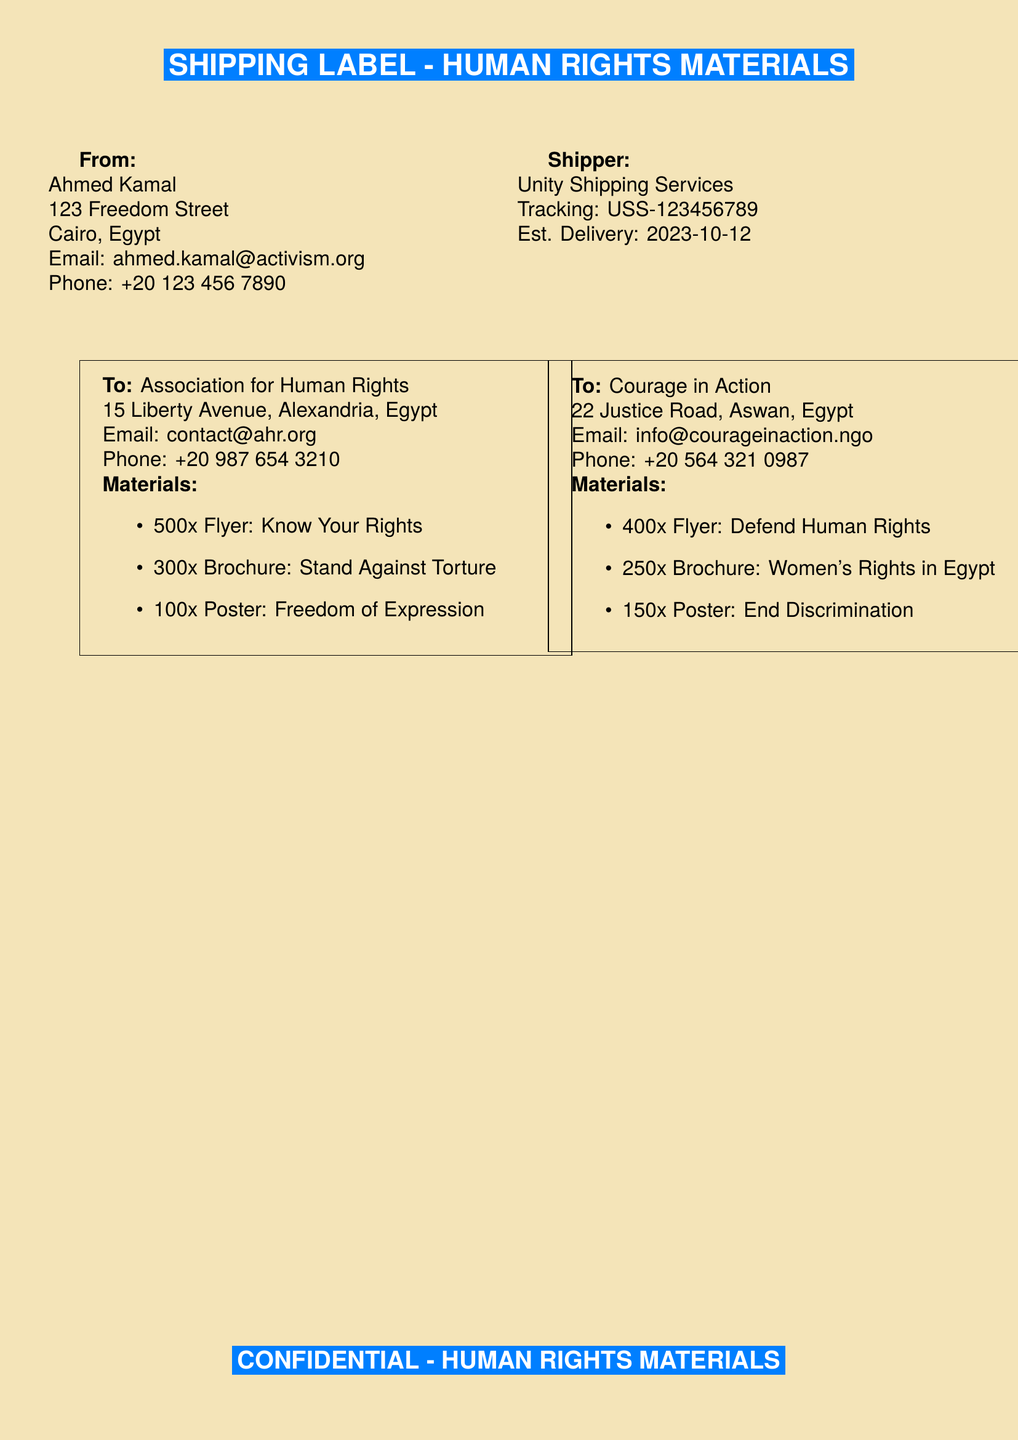what is the sender's name? The sender's name is provided in the "From" section of the document.
Answer: Ahmed Kamal what is the total number of flyers sent to both NGOs? The total number of flyers is the sum of flyers sent to each NGO, which is 500 + 400 = 900.
Answer: 900 how many posters are sent to the Association for Human Rights? The number of posters sent to the Association is listed in the "To" section corresponding to that NGO.
Answer: 100 what is the estimated delivery date? The estimated delivery date is given in the shipper information.
Answer: 2023-10-12 what is the email address of Courage in Action? The email address is specified in the contact details for Courage in Action.
Answer: info@courageinaction.ngo how many brochures are sent to Courage in Action? The number of brochures sent to Courage in Action is specified in the materials list for that NGO.
Answer: 250 what type of materials are included in this shipment? The types of materials are specified in the list under each NGO in the document.
Answer: Flyers, Brochures, Posters which shipping service is used? The shipping service is provided in the "Shipper" section of the document.
Answer: Unity Shipping Services what is the phone number of the Association for Human Rights? The phone number is located in the contact details for the Association for Human Rights.
Answer: +20 987 654 3210 